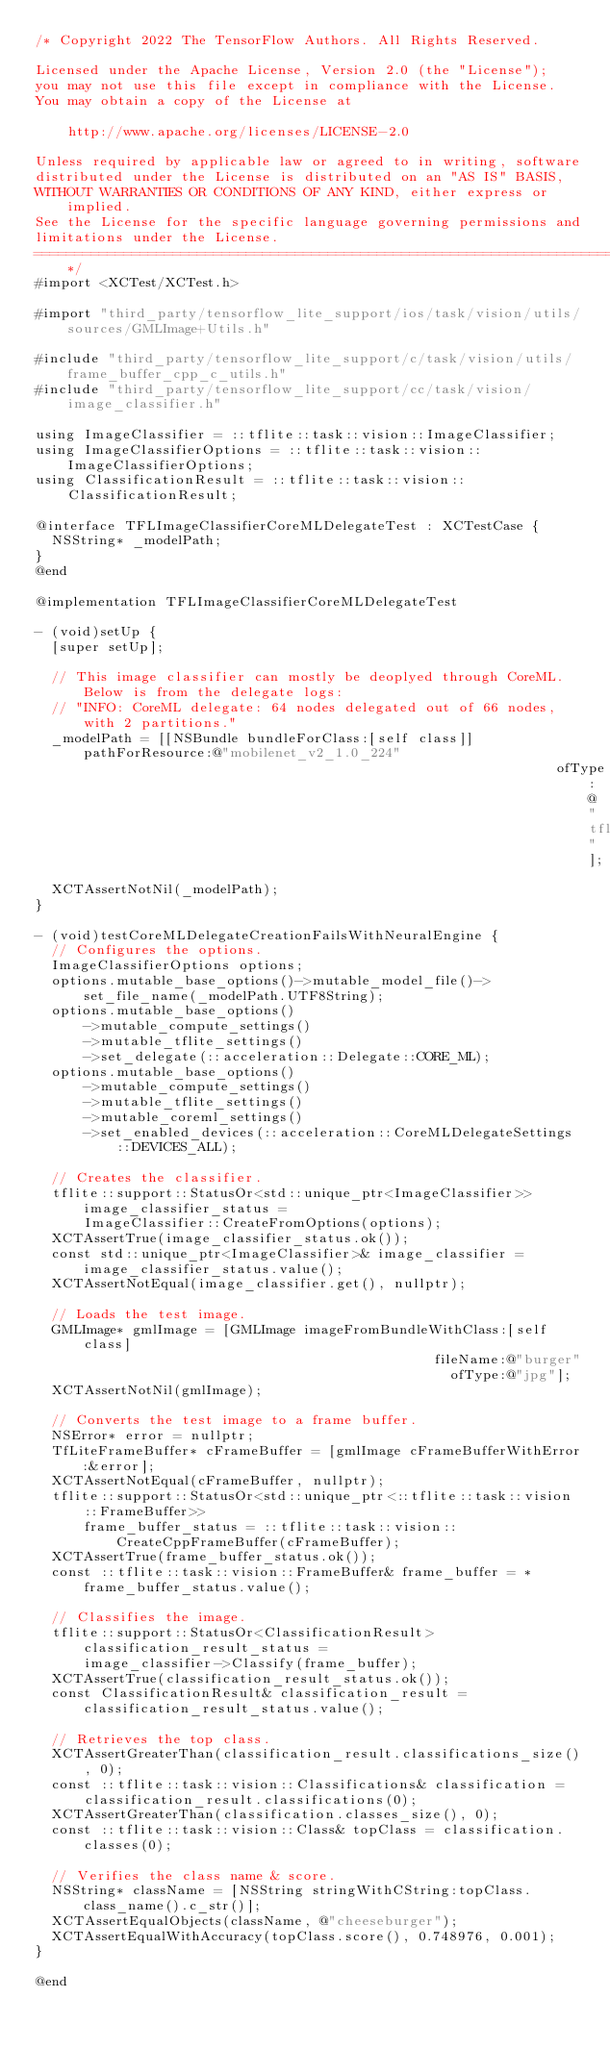<code> <loc_0><loc_0><loc_500><loc_500><_ObjectiveC_>/* Copyright 2022 The TensorFlow Authors. All Rights Reserved.

Licensed under the Apache License, Version 2.0 (the "License");
you may not use this file except in compliance with the License.
You may obtain a copy of the License at

    http://www.apache.org/licenses/LICENSE-2.0

Unless required by applicable law or agreed to in writing, software
distributed under the License is distributed on an "AS IS" BASIS,
WITHOUT WARRANTIES OR CONDITIONS OF ANY KIND, either express or implied.
See the License for the specific language governing permissions and
limitations under the License.
==============================================================================*/
#import <XCTest/XCTest.h>

#import "third_party/tensorflow_lite_support/ios/task/vision/utils/sources/GMLImage+Utils.h"

#include "third_party/tensorflow_lite_support/c/task/vision/utils/frame_buffer_cpp_c_utils.h"
#include "third_party/tensorflow_lite_support/cc/task/vision/image_classifier.h"

using ImageClassifier = ::tflite::task::vision::ImageClassifier;
using ImageClassifierOptions = ::tflite::task::vision::ImageClassifierOptions;
using ClassificationResult = ::tflite::task::vision::ClassificationResult;

@interface TFLImageClassifierCoreMLDelegateTest : XCTestCase {
  NSString* _modelPath;
}
@end

@implementation TFLImageClassifierCoreMLDelegateTest

- (void)setUp {
  [super setUp];

  // This image classifier can mostly be deoplyed through CoreML. Below is from the delegate logs:
  // "INFO: CoreML delegate: 64 nodes delegated out of 66 nodes, with 2 partitions."
  _modelPath = [[NSBundle bundleForClass:[self class]] pathForResource:@"mobilenet_v2_1.0_224"
                                                                ofType:@"tflite"];
  XCTAssertNotNil(_modelPath);
}

- (void)testCoreMLDelegateCreationFailsWithNeuralEngine {
  // Configures the options.
  ImageClassifierOptions options;
  options.mutable_base_options()->mutable_model_file()->set_file_name(_modelPath.UTF8String);
  options.mutable_base_options()
      ->mutable_compute_settings()
      ->mutable_tflite_settings()
      ->set_delegate(::acceleration::Delegate::CORE_ML);
  options.mutable_base_options()
      ->mutable_compute_settings()
      ->mutable_tflite_settings()
      ->mutable_coreml_settings()
      ->set_enabled_devices(::acceleration::CoreMLDelegateSettings::DEVICES_ALL);

  // Creates the classifier.
  tflite::support::StatusOr<std::unique_ptr<ImageClassifier>> image_classifier_status =
      ImageClassifier::CreateFromOptions(options);
  XCTAssertTrue(image_classifier_status.ok());
  const std::unique_ptr<ImageClassifier>& image_classifier = image_classifier_status.value();
  XCTAssertNotEqual(image_classifier.get(), nullptr);

  // Loads the test image.
  GMLImage* gmlImage = [GMLImage imageFromBundleWithClass:[self class]
                                                 fileName:@"burger"
                                                   ofType:@"jpg"];
  XCTAssertNotNil(gmlImage);

  // Converts the test image to a frame buffer.
  NSError* error = nullptr;
  TfLiteFrameBuffer* cFrameBuffer = [gmlImage cFrameBufferWithError:&error];
  XCTAssertNotEqual(cFrameBuffer, nullptr);
  tflite::support::StatusOr<std::unique_ptr<::tflite::task::vision::FrameBuffer>>
      frame_buffer_status = ::tflite::task::vision::CreateCppFrameBuffer(cFrameBuffer);
  XCTAssertTrue(frame_buffer_status.ok());
  const ::tflite::task::vision::FrameBuffer& frame_buffer = *frame_buffer_status.value();

  // Classifies the image.
  tflite::support::StatusOr<ClassificationResult> classification_result_status =
      image_classifier->Classify(frame_buffer);
  XCTAssertTrue(classification_result_status.ok());
  const ClassificationResult& classification_result = classification_result_status.value();

  // Retrieves the top class.
  XCTAssertGreaterThan(classification_result.classifications_size(), 0);
  const ::tflite::task::vision::Classifications& classification =
      classification_result.classifications(0);
  XCTAssertGreaterThan(classification.classes_size(), 0);
  const ::tflite::task::vision::Class& topClass = classification.classes(0);

  // Verifies the class name & score.
  NSString* className = [NSString stringWithCString:topClass.class_name().c_str()];
  XCTAssertEqualObjects(className, @"cheeseburger");
  XCTAssertEqualWithAccuracy(topClass.score(), 0.748976, 0.001);
}

@end
</code> 